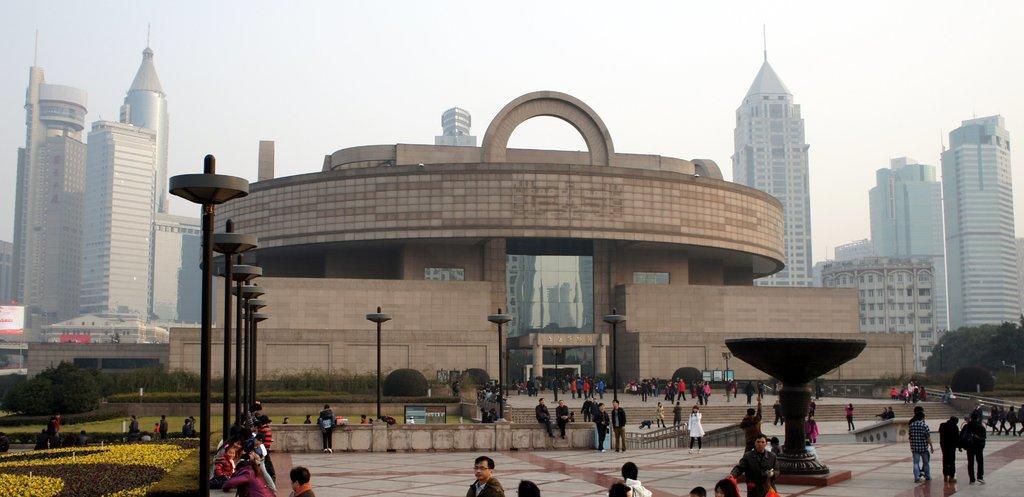How would you summarize this image in a sentence or two? In the image there are few people standing and walking on the floor with a huge building behind with plants in front of it, in the background there are skyscrapers and above its sky. 